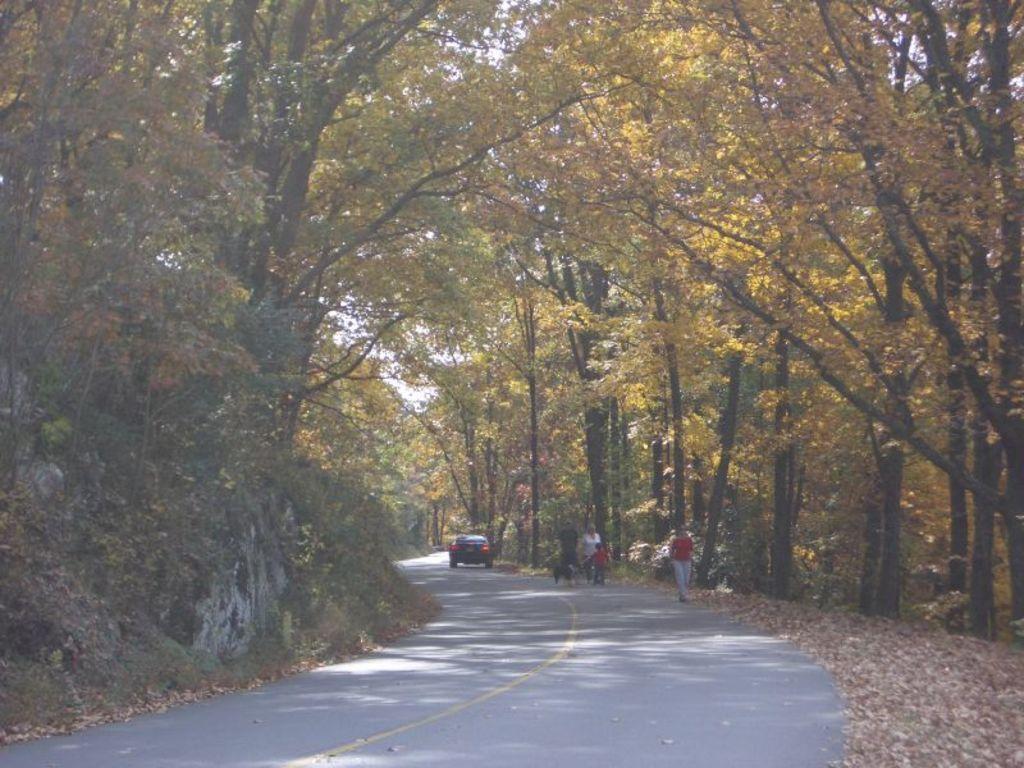Can you describe this image briefly? In the middle of the image few people are walking and we can see a dog. Behind them we can see a vehicle on the road. At the top of the image we can see some trees. 